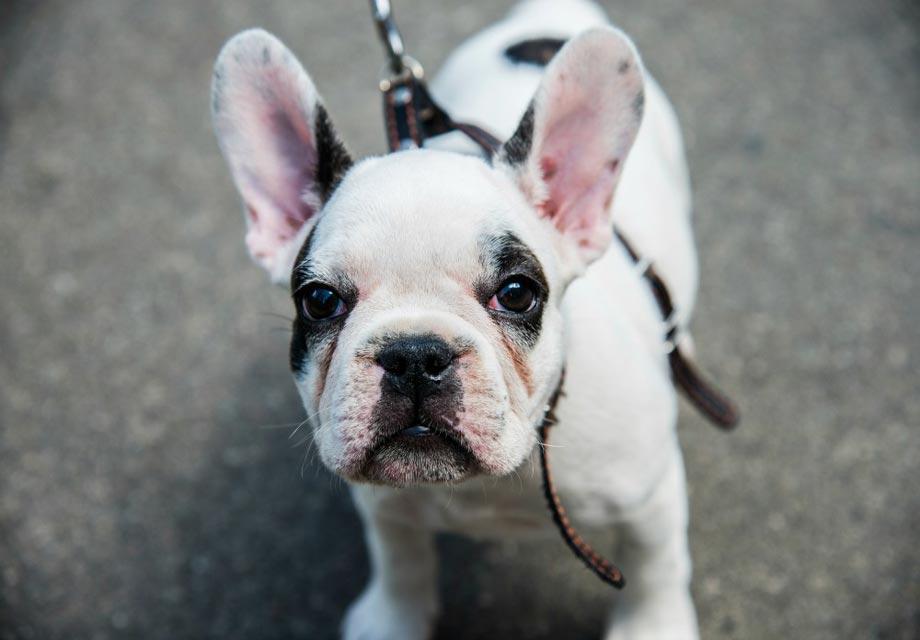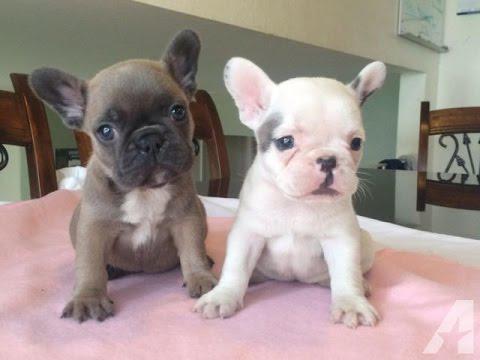The first image is the image on the left, the second image is the image on the right. Assess this claim about the two images: "One image shows exactly two real puppies posed on a plush surface.". Correct or not? Answer yes or no. Yes. The first image is the image on the left, the second image is the image on the right. Evaluate the accuracy of this statement regarding the images: "A total of three puppies are shown, most of them sitting.". Is it true? Answer yes or no. Yes. The first image is the image on the left, the second image is the image on the right. Examine the images to the left and right. Is the description "There are exactly three puppies." accurate? Answer yes or no. Yes. The first image is the image on the left, the second image is the image on the right. For the images displayed, is the sentence "There are exactly three dogs." factually correct? Answer yes or no. Yes. 